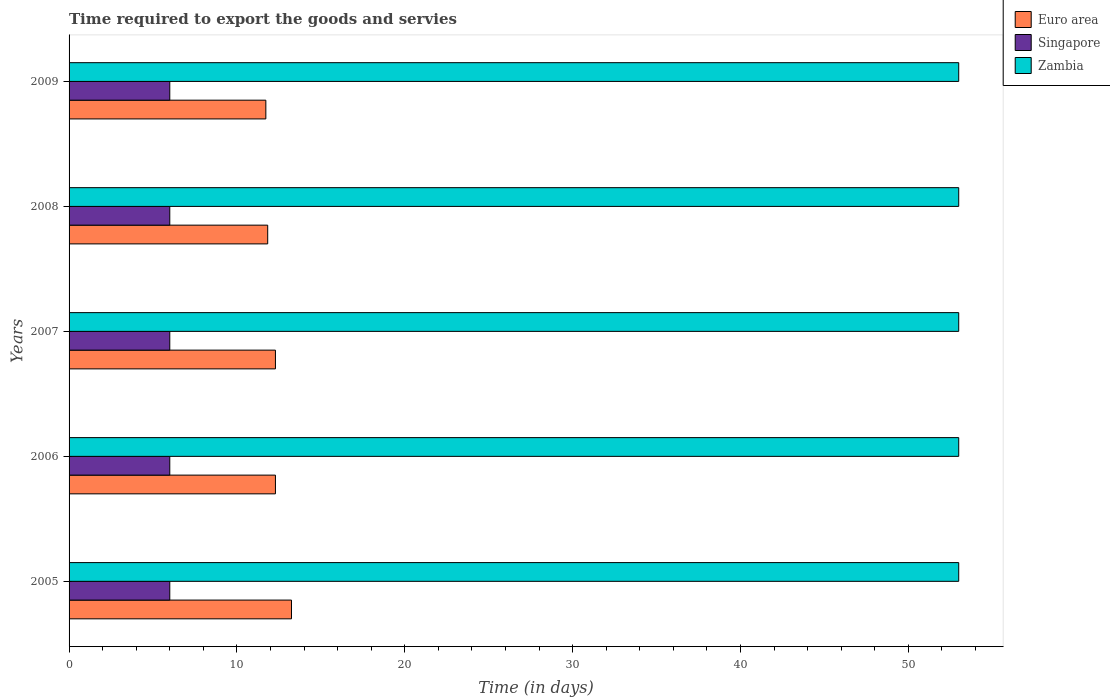How many different coloured bars are there?
Offer a terse response. 3. What is the label of the 4th group of bars from the top?
Offer a very short reply. 2006. What is the number of days required to export the goods and services in Singapore in 2006?
Ensure brevity in your answer.  6. Across all years, what is the maximum number of days required to export the goods and services in Zambia?
Offer a very short reply. 53. In which year was the number of days required to export the goods and services in Zambia maximum?
Your response must be concise. 2005. What is the total number of days required to export the goods and services in Zambia in the graph?
Provide a succinct answer. 265. What is the difference between the number of days required to export the goods and services in Zambia in 2006 and that in 2007?
Your answer should be very brief. 0. What is the difference between the number of days required to export the goods and services in Zambia in 2005 and the number of days required to export the goods and services in Euro area in 2008?
Make the answer very short. 41.17. What is the average number of days required to export the goods and services in Euro area per year?
Offer a very short reply. 12.28. In the year 2009, what is the difference between the number of days required to export the goods and services in Zambia and number of days required to export the goods and services in Euro area?
Offer a very short reply. 41.28. Is the number of days required to export the goods and services in Singapore in 2005 less than that in 2008?
Make the answer very short. No. What is the difference between the highest and the second highest number of days required to export the goods and services in Singapore?
Your answer should be very brief. 0. What is the difference between the highest and the lowest number of days required to export the goods and services in Singapore?
Provide a short and direct response. 0. In how many years, is the number of days required to export the goods and services in Euro area greater than the average number of days required to export the goods and services in Euro area taken over all years?
Keep it short and to the point. 3. Is the sum of the number of days required to export the goods and services in Singapore in 2006 and 2007 greater than the maximum number of days required to export the goods and services in Euro area across all years?
Keep it short and to the point. No. What does the 2nd bar from the top in 2005 represents?
Make the answer very short. Singapore. What does the 2nd bar from the bottom in 2008 represents?
Your response must be concise. Singapore. How many years are there in the graph?
Ensure brevity in your answer.  5. What is the difference between two consecutive major ticks on the X-axis?
Provide a succinct answer. 10. Does the graph contain any zero values?
Give a very brief answer. No. Does the graph contain grids?
Make the answer very short. No. What is the title of the graph?
Offer a terse response. Time required to export the goods and servies. What is the label or title of the X-axis?
Make the answer very short. Time (in days). What is the Time (in days) in Euro area in 2005?
Give a very brief answer. 13.25. What is the Time (in days) of Singapore in 2005?
Offer a terse response. 6. What is the Time (in days) of Zambia in 2005?
Offer a terse response. 53. What is the Time (in days) in Euro area in 2006?
Offer a very short reply. 12.29. What is the Time (in days) in Euro area in 2007?
Ensure brevity in your answer.  12.29. What is the Time (in days) of Singapore in 2007?
Give a very brief answer. 6. What is the Time (in days) in Euro area in 2008?
Provide a succinct answer. 11.83. What is the Time (in days) of Singapore in 2008?
Provide a short and direct response. 6. What is the Time (in days) of Zambia in 2008?
Ensure brevity in your answer.  53. What is the Time (in days) of Euro area in 2009?
Give a very brief answer. 11.72. What is the Time (in days) of Zambia in 2009?
Your response must be concise. 53. Across all years, what is the maximum Time (in days) of Euro area?
Provide a succinct answer. 13.25. Across all years, what is the minimum Time (in days) of Euro area?
Provide a succinct answer. 11.72. What is the total Time (in days) in Euro area in the graph?
Offer a terse response. 61.39. What is the total Time (in days) in Zambia in the graph?
Offer a very short reply. 265. What is the difference between the Time (in days) of Euro area in 2005 and that in 2006?
Your answer should be very brief. 0.96. What is the difference between the Time (in days) of Zambia in 2005 and that in 2006?
Keep it short and to the point. 0. What is the difference between the Time (in days) in Euro area in 2005 and that in 2007?
Your answer should be very brief. 0.96. What is the difference between the Time (in days) in Singapore in 2005 and that in 2007?
Offer a terse response. 0. What is the difference between the Time (in days) in Euro area in 2005 and that in 2008?
Ensure brevity in your answer.  1.42. What is the difference between the Time (in days) in Singapore in 2005 and that in 2008?
Provide a succinct answer. 0. What is the difference between the Time (in days) in Euro area in 2005 and that in 2009?
Your answer should be compact. 1.53. What is the difference between the Time (in days) in Singapore in 2005 and that in 2009?
Offer a terse response. 0. What is the difference between the Time (in days) of Zambia in 2005 and that in 2009?
Make the answer very short. 0. What is the difference between the Time (in days) of Euro area in 2006 and that in 2008?
Your answer should be very brief. 0.46. What is the difference between the Time (in days) in Euro area in 2006 and that in 2009?
Your answer should be very brief. 0.57. What is the difference between the Time (in days) in Zambia in 2006 and that in 2009?
Your answer should be very brief. 0. What is the difference between the Time (in days) of Euro area in 2007 and that in 2008?
Your response must be concise. 0.46. What is the difference between the Time (in days) in Singapore in 2007 and that in 2008?
Keep it short and to the point. 0. What is the difference between the Time (in days) in Zambia in 2007 and that in 2008?
Provide a succinct answer. 0. What is the difference between the Time (in days) in Euro area in 2007 and that in 2009?
Provide a succinct answer. 0.57. What is the difference between the Time (in days) in Singapore in 2007 and that in 2009?
Make the answer very short. 0. What is the difference between the Time (in days) of Euro area in 2008 and that in 2009?
Your answer should be compact. 0.11. What is the difference between the Time (in days) of Euro area in 2005 and the Time (in days) of Singapore in 2006?
Make the answer very short. 7.25. What is the difference between the Time (in days) in Euro area in 2005 and the Time (in days) in Zambia in 2006?
Give a very brief answer. -39.75. What is the difference between the Time (in days) in Singapore in 2005 and the Time (in days) in Zambia in 2006?
Make the answer very short. -47. What is the difference between the Time (in days) of Euro area in 2005 and the Time (in days) of Singapore in 2007?
Offer a very short reply. 7.25. What is the difference between the Time (in days) in Euro area in 2005 and the Time (in days) in Zambia in 2007?
Offer a terse response. -39.75. What is the difference between the Time (in days) in Singapore in 2005 and the Time (in days) in Zambia in 2007?
Make the answer very short. -47. What is the difference between the Time (in days) of Euro area in 2005 and the Time (in days) of Singapore in 2008?
Provide a succinct answer. 7.25. What is the difference between the Time (in days) of Euro area in 2005 and the Time (in days) of Zambia in 2008?
Offer a terse response. -39.75. What is the difference between the Time (in days) of Singapore in 2005 and the Time (in days) of Zambia in 2008?
Your answer should be very brief. -47. What is the difference between the Time (in days) of Euro area in 2005 and the Time (in days) of Singapore in 2009?
Your response must be concise. 7.25. What is the difference between the Time (in days) of Euro area in 2005 and the Time (in days) of Zambia in 2009?
Make the answer very short. -39.75. What is the difference between the Time (in days) of Singapore in 2005 and the Time (in days) of Zambia in 2009?
Your response must be concise. -47. What is the difference between the Time (in days) of Euro area in 2006 and the Time (in days) of Singapore in 2007?
Provide a short and direct response. 6.29. What is the difference between the Time (in days) of Euro area in 2006 and the Time (in days) of Zambia in 2007?
Your response must be concise. -40.71. What is the difference between the Time (in days) of Singapore in 2006 and the Time (in days) of Zambia in 2007?
Your answer should be very brief. -47. What is the difference between the Time (in days) of Euro area in 2006 and the Time (in days) of Singapore in 2008?
Your answer should be compact. 6.29. What is the difference between the Time (in days) of Euro area in 2006 and the Time (in days) of Zambia in 2008?
Your answer should be very brief. -40.71. What is the difference between the Time (in days) in Singapore in 2006 and the Time (in days) in Zambia in 2008?
Provide a short and direct response. -47. What is the difference between the Time (in days) of Euro area in 2006 and the Time (in days) of Singapore in 2009?
Provide a succinct answer. 6.29. What is the difference between the Time (in days) of Euro area in 2006 and the Time (in days) of Zambia in 2009?
Give a very brief answer. -40.71. What is the difference between the Time (in days) in Singapore in 2006 and the Time (in days) in Zambia in 2009?
Offer a terse response. -47. What is the difference between the Time (in days) in Euro area in 2007 and the Time (in days) in Singapore in 2008?
Give a very brief answer. 6.29. What is the difference between the Time (in days) in Euro area in 2007 and the Time (in days) in Zambia in 2008?
Give a very brief answer. -40.71. What is the difference between the Time (in days) in Singapore in 2007 and the Time (in days) in Zambia in 2008?
Make the answer very short. -47. What is the difference between the Time (in days) of Euro area in 2007 and the Time (in days) of Singapore in 2009?
Offer a terse response. 6.29. What is the difference between the Time (in days) in Euro area in 2007 and the Time (in days) in Zambia in 2009?
Offer a very short reply. -40.71. What is the difference between the Time (in days) in Singapore in 2007 and the Time (in days) in Zambia in 2009?
Your answer should be compact. -47. What is the difference between the Time (in days) of Euro area in 2008 and the Time (in days) of Singapore in 2009?
Keep it short and to the point. 5.83. What is the difference between the Time (in days) in Euro area in 2008 and the Time (in days) in Zambia in 2009?
Offer a very short reply. -41.17. What is the difference between the Time (in days) in Singapore in 2008 and the Time (in days) in Zambia in 2009?
Your response must be concise. -47. What is the average Time (in days) of Euro area per year?
Your response must be concise. 12.28. What is the average Time (in days) of Zambia per year?
Provide a succinct answer. 53. In the year 2005, what is the difference between the Time (in days) of Euro area and Time (in days) of Singapore?
Ensure brevity in your answer.  7.25. In the year 2005, what is the difference between the Time (in days) of Euro area and Time (in days) of Zambia?
Ensure brevity in your answer.  -39.75. In the year 2005, what is the difference between the Time (in days) in Singapore and Time (in days) in Zambia?
Keep it short and to the point. -47. In the year 2006, what is the difference between the Time (in days) in Euro area and Time (in days) in Singapore?
Offer a very short reply. 6.29. In the year 2006, what is the difference between the Time (in days) of Euro area and Time (in days) of Zambia?
Offer a terse response. -40.71. In the year 2006, what is the difference between the Time (in days) of Singapore and Time (in days) of Zambia?
Provide a succinct answer. -47. In the year 2007, what is the difference between the Time (in days) of Euro area and Time (in days) of Singapore?
Offer a terse response. 6.29. In the year 2007, what is the difference between the Time (in days) of Euro area and Time (in days) of Zambia?
Give a very brief answer. -40.71. In the year 2007, what is the difference between the Time (in days) in Singapore and Time (in days) in Zambia?
Provide a short and direct response. -47. In the year 2008, what is the difference between the Time (in days) of Euro area and Time (in days) of Singapore?
Keep it short and to the point. 5.83. In the year 2008, what is the difference between the Time (in days) of Euro area and Time (in days) of Zambia?
Give a very brief answer. -41.17. In the year 2008, what is the difference between the Time (in days) of Singapore and Time (in days) of Zambia?
Provide a short and direct response. -47. In the year 2009, what is the difference between the Time (in days) in Euro area and Time (in days) in Singapore?
Make the answer very short. 5.72. In the year 2009, what is the difference between the Time (in days) in Euro area and Time (in days) in Zambia?
Your response must be concise. -41.28. In the year 2009, what is the difference between the Time (in days) in Singapore and Time (in days) in Zambia?
Your answer should be compact. -47. What is the ratio of the Time (in days) of Euro area in 2005 to that in 2006?
Provide a succinct answer. 1.08. What is the ratio of the Time (in days) of Singapore in 2005 to that in 2006?
Make the answer very short. 1. What is the ratio of the Time (in days) in Euro area in 2005 to that in 2007?
Provide a succinct answer. 1.08. What is the ratio of the Time (in days) in Singapore in 2005 to that in 2007?
Your answer should be very brief. 1. What is the ratio of the Time (in days) of Euro area in 2005 to that in 2008?
Offer a very short reply. 1.12. What is the ratio of the Time (in days) of Singapore in 2005 to that in 2008?
Give a very brief answer. 1. What is the ratio of the Time (in days) of Euro area in 2005 to that in 2009?
Offer a terse response. 1.13. What is the ratio of the Time (in days) in Euro area in 2006 to that in 2008?
Your response must be concise. 1.04. What is the ratio of the Time (in days) of Singapore in 2006 to that in 2008?
Ensure brevity in your answer.  1. What is the ratio of the Time (in days) of Euro area in 2006 to that in 2009?
Provide a short and direct response. 1.05. What is the ratio of the Time (in days) of Zambia in 2006 to that in 2009?
Make the answer very short. 1. What is the ratio of the Time (in days) in Euro area in 2007 to that in 2008?
Your answer should be very brief. 1.04. What is the ratio of the Time (in days) in Euro area in 2007 to that in 2009?
Offer a terse response. 1.05. What is the ratio of the Time (in days) in Euro area in 2008 to that in 2009?
Your answer should be very brief. 1.01. What is the ratio of the Time (in days) in Singapore in 2008 to that in 2009?
Provide a succinct answer. 1. What is the ratio of the Time (in days) in Zambia in 2008 to that in 2009?
Provide a succinct answer. 1. What is the difference between the highest and the second highest Time (in days) of Euro area?
Offer a very short reply. 0.96. What is the difference between the highest and the second highest Time (in days) in Singapore?
Your response must be concise. 0. What is the difference between the highest and the second highest Time (in days) in Zambia?
Offer a very short reply. 0. What is the difference between the highest and the lowest Time (in days) of Euro area?
Make the answer very short. 1.53. What is the difference between the highest and the lowest Time (in days) in Singapore?
Offer a terse response. 0. 